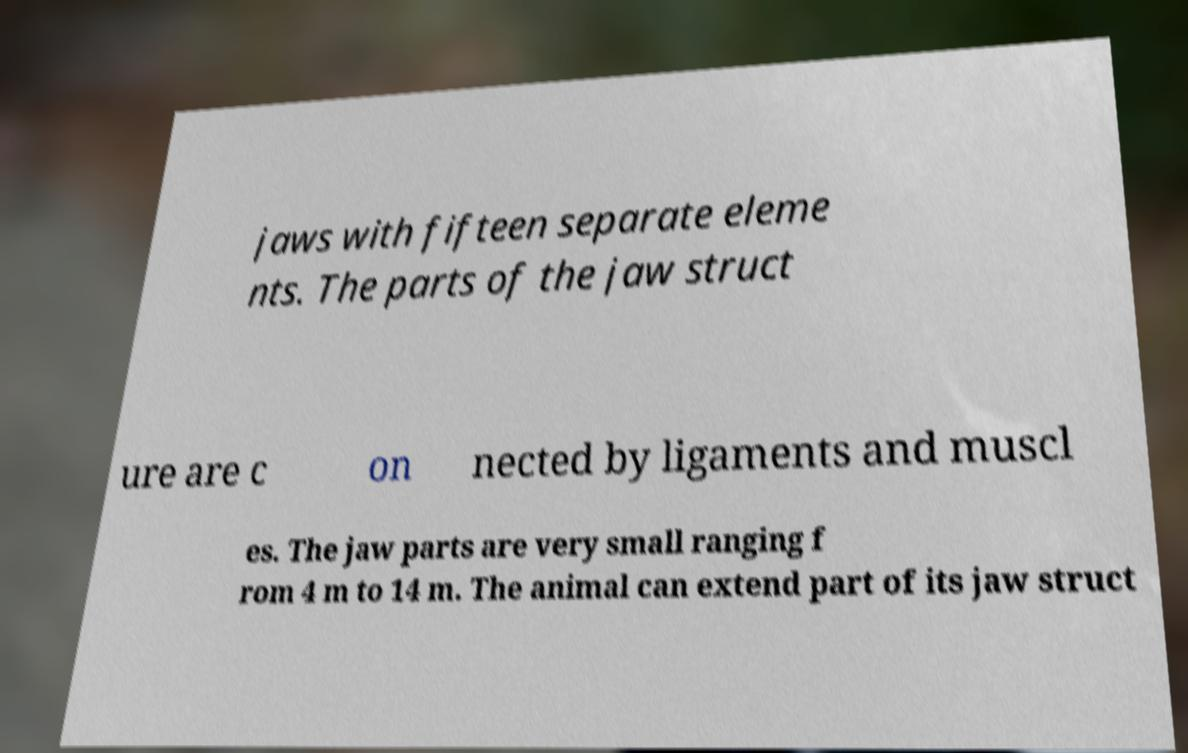Could you assist in decoding the text presented in this image and type it out clearly? jaws with fifteen separate eleme nts. The parts of the jaw struct ure are c on nected by ligaments and muscl es. The jaw parts are very small ranging f rom 4 m to 14 m. The animal can extend part of its jaw struct 